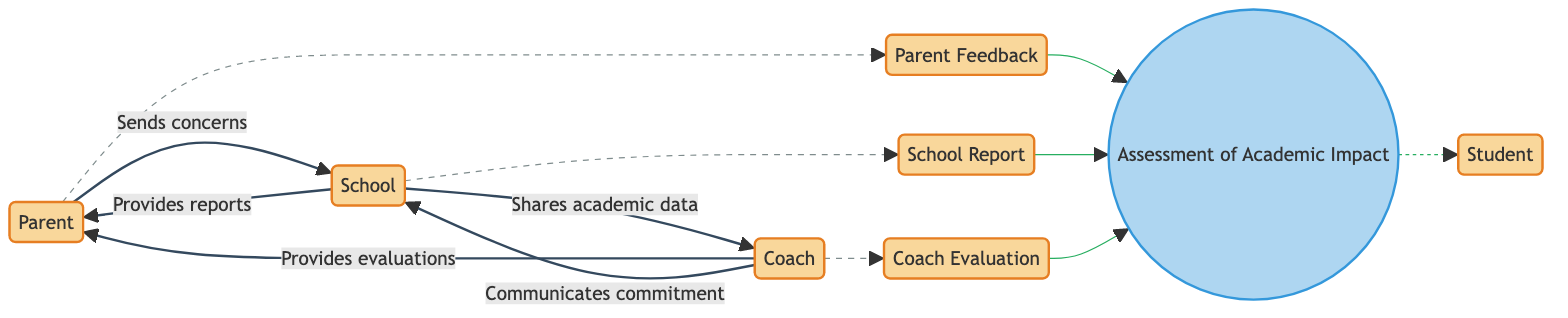What are the main entities in the diagram? The main entities are Parent, Student, Coach, School, School Report, Parent Feedback, and Coach Evaluation. Each one is depicted as a node in the diagram, showcasing their distinct roles and relationships.
Answer: Parent, Student, Coach, School, School Report, Parent Feedback, Coach Evaluation How many data flows are shown in the diagram? There are five data flows indicated in the diagram. Each flow connects two entities, demonstrating the exchange of information between them.
Answer: Five What is the purpose of the assessment process? The assessment process evaluates the impact of the demanding coaching approach on the student's academic performance. This is represented in the diagram where the process node is labeled accordingly.
Answer: Evaluates impact Which entity provides evaluations of the student's sports performance? The Coach provides evaluations of the student's sports performance as indicated by the arrow directing from Coach to Parent in the diagram.
Answer: Coach How does the School contribute to the assessment? The School contributes to the assessment by providing school reports and sharing academic performance data with the Coach, which are both inputs into the assessment process.
Answer: By providing reports and sharing data Describe the flow of information from the Parent to the School. The Parent sends concerns and feedback about the student’s well-being to the School, which is depicted by the arrow flowing from the Parent to School.
Answer: Sends concerns and feedback What type of feedback is received from the Parent? The feedback received from the Parent is labeled as Parent Feedback, which is depicted as an input to the assessment process in the diagram.
Answer: Parent Feedback What does the Coach communicate to the School? The Coach communicates the student's commitment and time management to the School, as indicated by the corresponding data flow in the diagram.
Answer: Commitment and time management 